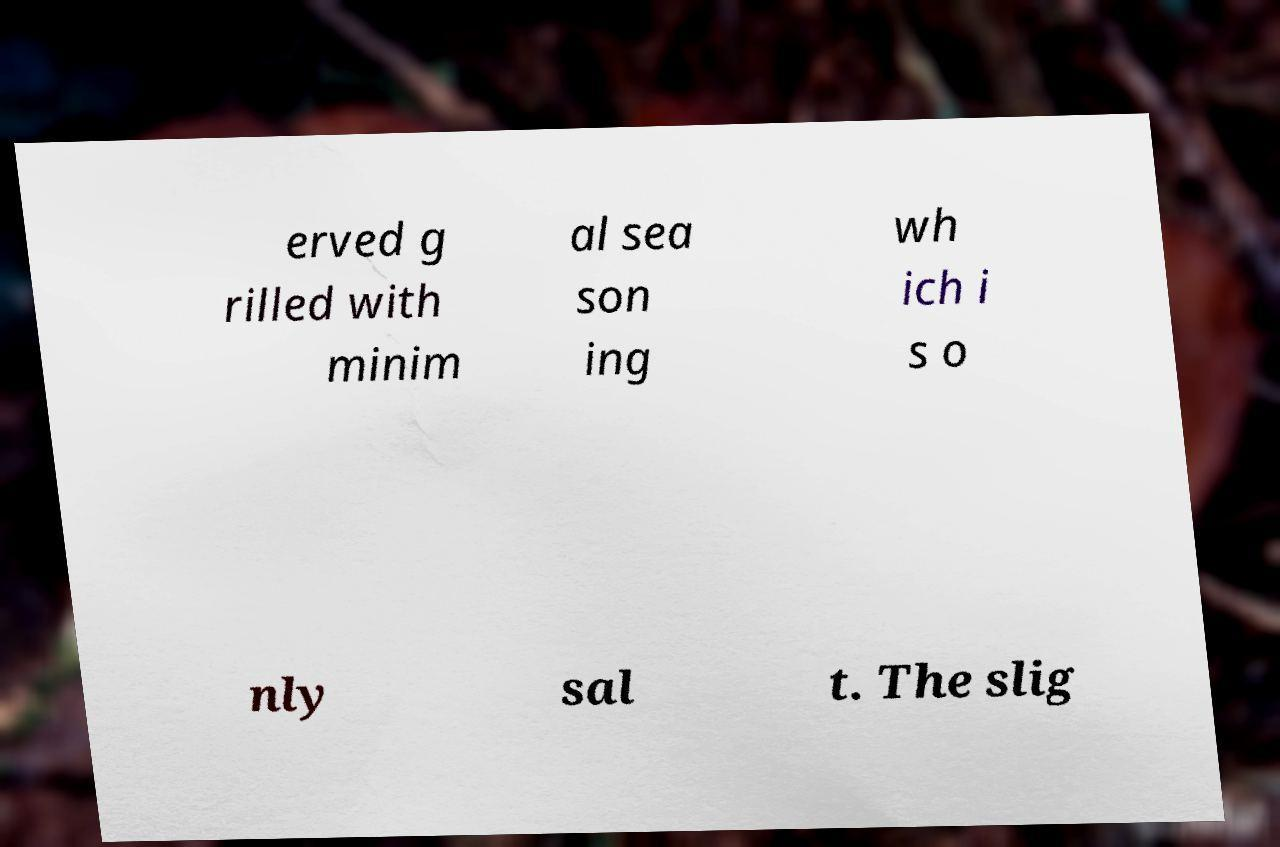What messages or text are displayed in this image? I need them in a readable, typed format. erved g rilled with minim al sea son ing wh ich i s o nly sal t. The slig 